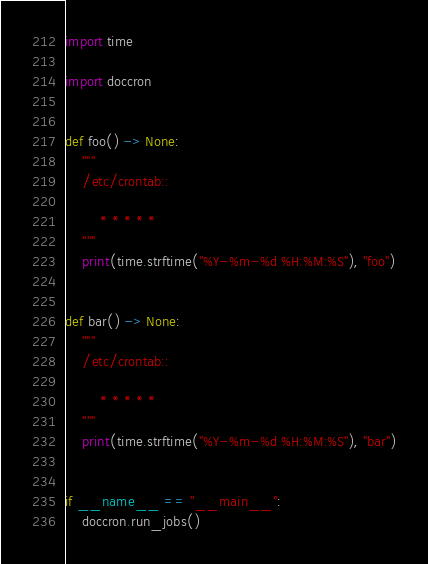Convert code to text. <code><loc_0><loc_0><loc_500><loc_500><_Python_>import time

import doccron


def foo() -> None:
    """
    /etc/crontab::

        * * * * *
    """
    print(time.strftime("%Y-%m-%d %H:%M:%S"), "foo")


def bar() -> None:
    """
    /etc/crontab::

        * * * * *
    """
    print(time.strftime("%Y-%m-%d %H:%M:%S"), "bar")


if __name__ == "__main__":
    doccron.run_jobs()
</code> 